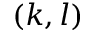<formula> <loc_0><loc_0><loc_500><loc_500>( k , l )</formula> 